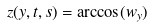<formula> <loc_0><loc_0><loc_500><loc_500>z ( y , t , s ) = \arccos ( w _ { y } )</formula> 